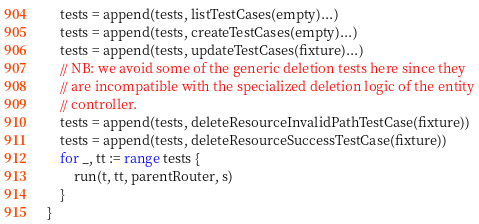Convert code to text. <code><loc_0><loc_0><loc_500><loc_500><_Go_>	tests = append(tests, listTestCases(empty)...)
	tests = append(tests, createTestCases(empty)...)
	tests = append(tests, updateTestCases(fixture)...)
	// NB: we avoid some of the generic deletion tests here since they
	// are incompatible with the specialized deletion logic of the entity
	// controller.
	tests = append(tests, deleteResourceInvalidPathTestCase(fixture))
	tests = append(tests, deleteResourceSuccessTestCase(fixture))
	for _, tt := range tests {
		run(t, tt, parentRouter, s)
	}
}
</code> 